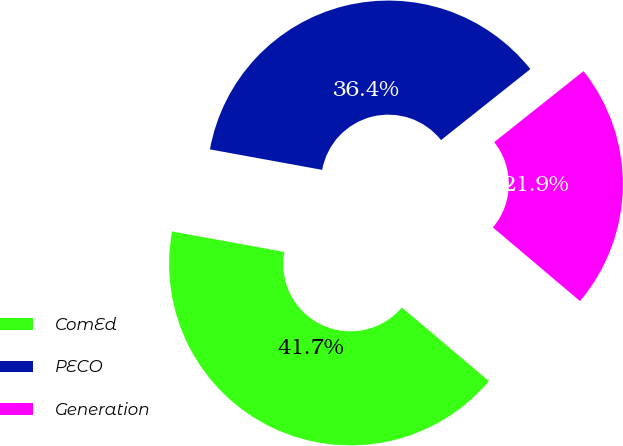Convert chart to OTSL. <chart><loc_0><loc_0><loc_500><loc_500><pie_chart><fcel>ComEd<fcel>PECO<fcel>Generation<nl><fcel>41.7%<fcel>36.44%<fcel>21.86%<nl></chart> 